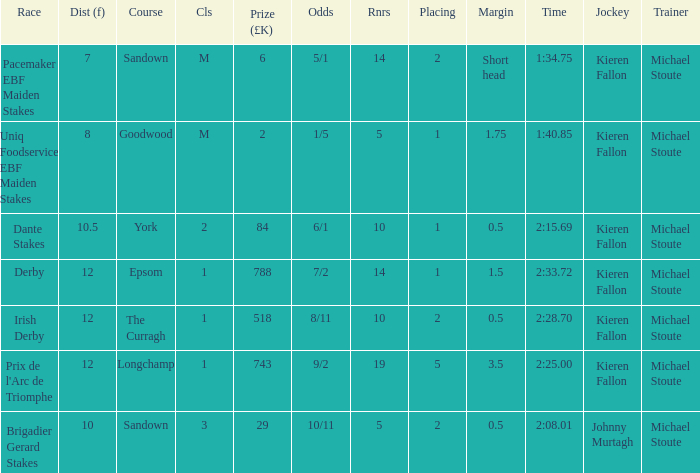Name the least runners with dist of 10.5 10.0. 